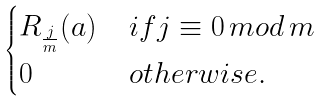Convert formula to latex. <formula><loc_0><loc_0><loc_500><loc_500>\begin{cases} R _ { \frac { j } { m } } ( a ) & \, i f j \equiv 0 \, m o d \, m \\ 0 & \, o t h e r w i s e . \end{cases}</formula> 